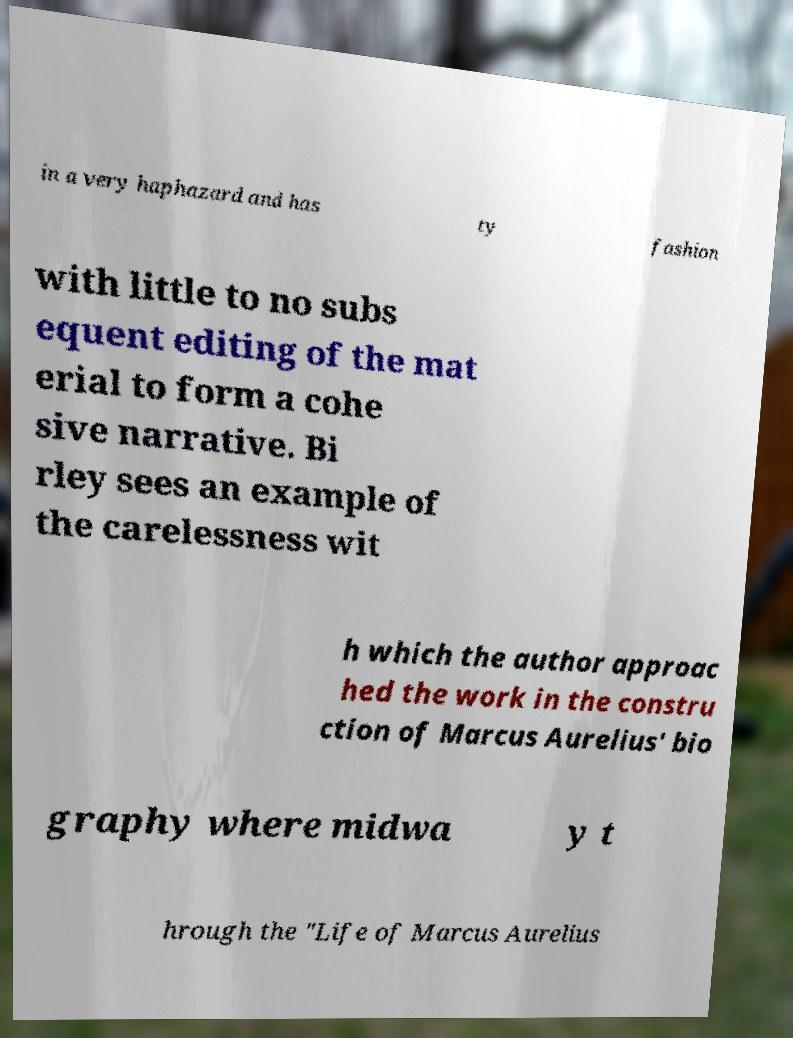Could you assist in decoding the text presented in this image and type it out clearly? in a very haphazard and has ty fashion with little to no subs equent editing of the mat erial to form a cohe sive narrative. Bi rley sees an example of the carelessness wit h which the author approac hed the work in the constru ction of Marcus Aurelius' bio graphy where midwa y t hrough the "Life of Marcus Aurelius 